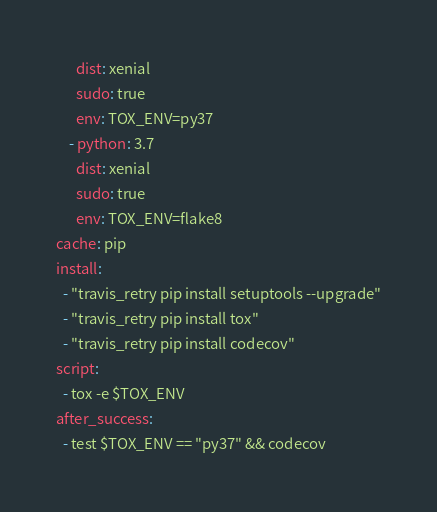Convert code to text. <code><loc_0><loc_0><loc_500><loc_500><_YAML_>      dist: xenial
      sudo: true
      env: TOX_ENV=py37
    - python: 3.7
      dist: xenial
      sudo: true
      env: TOX_ENV=flake8
cache: pip
install:
  - "travis_retry pip install setuptools --upgrade"
  - "travis_retry pip install tox"
  - "travis_retry pip install codecov"
script:
  - tox -e $TOX_ENV
after_success:
  - test $TOX_ENV == "py37" && codecov</code> 